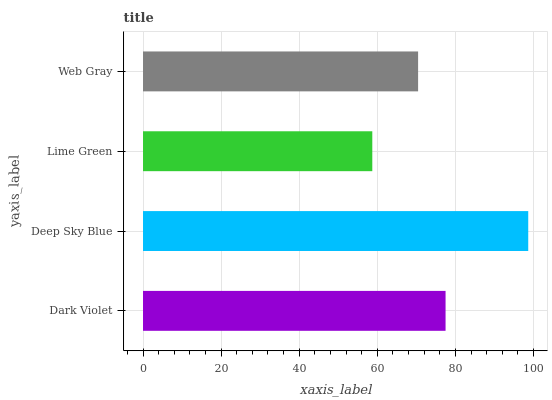Is Lime Green the minimum?
Answer yes or no. Yes. Is Deep Sky Blue the maximum?
Answer yes or no. Yes. Is Deep Sky Blue the minimum?
Answer yes or no. No. Is Lime Green the maximum?
Answer yes or no. No. Is Deep Sky Blue greater than Lime Green?
Answer yes or no. Yes. Is Lime Green less than Deep Sky Blue?
Answer yes or no. Yes. Is Lime Green greater than Deep Sky Blue?
Answer yes or no. No. Is Deep Sky Blue less than Lime Green?
Answer yes or no. No. Is Dark Violet the high median?
Answer yes or no. Yes. Is Web Gray the low median?
Answer yes or no. Yes. Is Lime Green the high median?
Answer yes or no. No. Is Lime Green the low median?
Answer yes or no. No. 